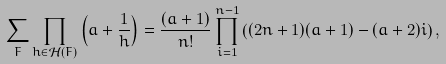<formula> <loc_0><loc_0><loc_500><loc_500>\sum _ { F } \prod _ { h \in \mathcal { H } ( F ) } \left ( a + \frac { 1 } { h } \right ) = \frac { ( a + 1 ) } { n ! } \prod _ { i = 1 } ^ { n - 1 } \left ( ( 2 n + 1 ) ( a + 1 ) - ( a + 2 ) i \right ) ,</formula> 